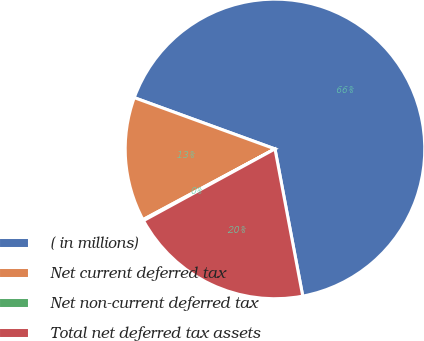Convert chart to OTSL. <chart><loc_0><loc_0><loc_500><loc_500><pie_chart><fcel>( in millions)<fcel>Net current deferred tax<fcel>Net non-current deferred tax<fcel>Total net deferred tax assets<nl><fcel>66.47%<fcel>13.39%<fcel>0.12%<fcel>20.02%<nl></chart> 